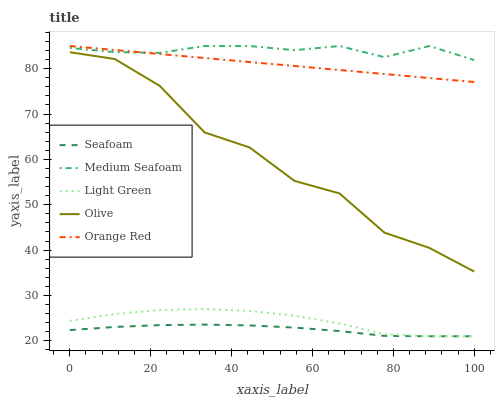Does Seafoam have the minimum area under the curve?
Answer yes or no. Yes. Does Medium Seafoam have the maximum area under the curve?
Answer yes or no. Yes. Does Orange Red have the minimum area under the curve?
Answer yes or no. No. Does Orange Red have the maximum area under the curve?
Answer yes or no. No. Is Orange Red the smoothest?
Answer yes or no. Yes. Is Olive the roughest?
Answer yes or no. Yes. Is Seafoam the smoothest?
Answer yes or no. No. Is Seafoam the roughest?
Answer yes or no. No. Does Orange Red have the lowest value?
Answer yes or no. No. Does Medium Seafoam have the highest value?
Answer yes or no. Yes. Does Seafoam have the highest value?
Answer yes or no. No. Is Seafoam less than Olive?
Answer yes or no. Yes. Is Medium Seafoam greater than Olive?
Answer yes or no. Yes. Does Seafoam intersect Light Green?
Answer yes or no. Yes. Is Seafoam less than Light Green?
Answer yes or no. No. Is Seafoam greater than Light Green?
Answer yes or no. No. Does Seafoam intersect Olive?
Answer yes or no. No. 